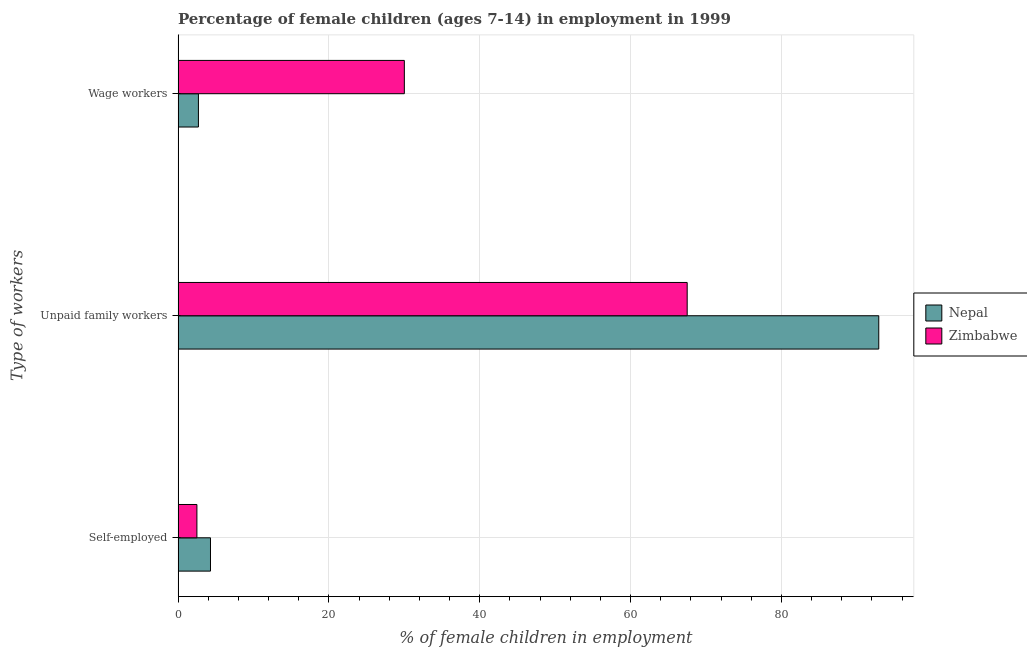How many different coloured bars are there?
Offer a very short reply. 2. Are the number of bars per tick equal to the number of legend labels?
Offer a terse response. Yes. How many bars are there on the 3rd tick from the top?
Give a very brief answer. 2. What is the label of the 1st group of bars from the top?
Make the answer very short. Wage workers. Across all countries, what is the maximum percentage of self employed children?
Give a very brief answer. 4.3. Across all countries, what is the minimum percentage of children employed as unpaid family workers?
Your answer should be very brief. 67.5. In which country was the percentage of self employed children maximum?
Provide a short and direct response. Nepal. In which country was the percentage of self employed children minimum?
Your answer should be very brief. Zimbabwe. What is the total percentage of children employed as unpaid family workers in the graph?
Ensure brevity in your answer.  160.4. What is the difference between the percentage of children employed as unpaid family workers in Nepal and that in Zimbabwe?
Your answer should be compact. 25.4. What is the difference between the percentage of children employed as unpaid family workers in Zimbabwe and the percentage of children employed as wage workers in Nepal?
Keep it short and to the point. 64.8. What is the difference between the percentage of children employed as unpaid family workers and percentage of children employed as wage workers in Nepal?
Provide a succinct answer. 90.2. What is the ratio of the percentage of children employed as wage workers in Nepal to that in Zimbabwe?
Your response must be concise. 0.09. What is the difference between the highest and the second highest percentage of children employed as wage workers?
Keep it short and to the point. 27.3. What is the difference between the highest and the lowest percentage of children employed as unpaid family workers?
Your answer should be very brief. 25.4. What does the 2nd bar from the top in Self-employed represents?
Provide a short and direct response. Nepal. What does the 1st bar from the bottom in Self-employed represents?
Provide a succinct answer. Nepal. Is it the case that in every country, the sum of the percentage of self employed children and percentage of children employed as unpaid family workers is greater than the percentage of children employed as wage workers?
Your response must be concise. Yes. Are all the bars in the graph horizontal?
Give a very brief answer. Yes. What is the difference between two consecutive major ticks on the X-axis?
Offer a terse response. 20. Does the graph contain any zero values?
Keep it short and to the point. No. How are the legend labels stacked?
Your response must be concise. Vertical. What is the title of the graph?
Offer a very short reply. Percentage of female children (ages 7-14) in employment in 1999. Does "Malaysia" appear as one of the legend labels in the graph?
Ensure brevity in your answer.  No. What is the label or title of the X-axis?
Ensure brevity in your answer.  % of female children in employment. What is the label or title of the Y-axis?
Your answer should be compact. Type of workers. What is the % of female children in employment in Zimbabwe in Self-employed?
Provide a succinct answer. 2.5. What is the % of female children in employment of Nepal in Unpaid family workers?
Keep it short and to the point. 92.9. What is the % of female children in employment in Zimbabwe in Unpaid family workers?
Ensure brevity in your answer.  67.5. What is the % of female children in employment in Zimbabwe in Wage workers?
Give a very brief answer. 30. Across all Type of workers, what is the maximum % of female children in employment in Nepal?
Offer a terse response. 92.9. Across all Type of workers, what is the maximum % of female children in employment in Zimbabwe?
Make the answer very short. 67.5. Across all Type of workers, what is the minimum % of female children in employment in Zimbabwe?
Give a very brief answer. 2.5. What is the total % of female children in employment of Nepal in the graph?
Ensure brevity in your answer.  99.9. What is the difference between the % of female children in employment in Nepal in Self-employed and that in Unpaid family workers?
Make the answer very short. -88.6. What is the difference between the % of female children in employment in Zimbabwe in Self-employed and that in Unpaid family workers?
Offer a terse response. -65. What is the difference between the % of female children in employment of Zimbabwe in Self-employed and that in Wage workers?
Offer a very short reply. -27.5. What is the difference between the % of female children in employment of Nepal in Unpaid family workers and that in Wage workers?
Offer a very short reply. 90.2. What is the difference between the % of female children in employment in Zimbabwe in Unpaid family workers and that in Wage workers?
Provide a succinct answer. 37.5. What is the difference between the % of female children in employment of Nepal in Self-employed and the % of female children in employment of Zimbabwe in Unpaid family workers?
Make the answer very short. -63.2. What is the difference between the % of female children in employment of Nepal in Self-employed and the % of female children in employment of Zimbabwe in Wage workers?
Your answer should be compact. -25.7. What is the difference between the % of female children in employment in Nepal in Unpaid family workers and the % of female children in employment in Zimbabwe in Wage workers?
Provide a succinct answer. 62.9. What is the average % of female children in employment in Nepal per Type of workers?
Your answer should be compact. 33.3. What is the average % of female children in employment in Zimbabwe per Type of workers?
Your answer should be very brief. 33.33. What is the difference between the % of female children in employment of Nepal and % of female children in employment of Zimbabwe in Unpaid family workers?
Your answer should be compact. 25.4. What is the difference between the % of female children in employment in Nepal and % of female children in employment in Zimbabwe in Wage workers?
Offer a very short reply. -27.3. What is the ratio of the % of female children in employment in Nepal in Self-employed to that in Unpaid family workers?
Your answer should be compact. 0.05. What is the ratio of the % of female children in employment in Zimbabwe in Self-employed to that in Unpaid family workers?
Provide a short and direct response. 0.04. What is the ratio of the % of female children in employment of Nepal in Self-employed to that in Wage workers?
Keep it short and to the point. 1.59. What is the ratio of the % of female children in employment in Zimbabwe in Self-employed to that in Wage workers?
Give a very brief answer. 0.08. What is the ratio of the % of female children in employment of Nepal in Unpaid family workers to that in Wage workers?
Offer a terse response. 34.41. What is the ratio of the % of female children in employment of Zimbabwe in Unpaid family workers to that in Wage workers?
Offer a very short reply. 2.25. What is the difference between the highest and the second highest % of female children in employment in Nepal?
Offer a terse response. 88.6. What is the difference between the highest and the second highest % of female children in employment in Zimbabwe?
Ensure brevity in your answer.  37.5. What is the difference between the highest and the lowest % of female children in employment in Nepal?
Keep it short and to the point. 90.2. 